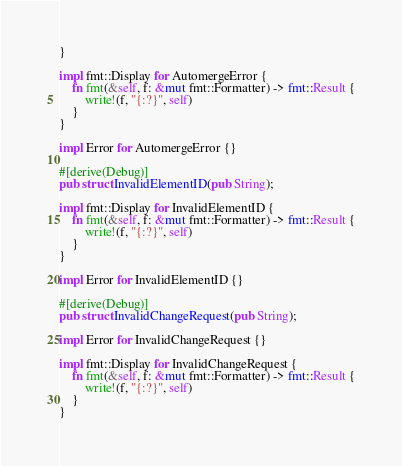<code> <loc_0><loc_0><loc_500><loc_500><_Rust_>}

impl fmt::Display for AutomergeError {
    fn fmt(&self, f: &mut fmt::Formatter) -> fmt::Result {
        write!(f, "{:?}", self)
    }
}

impl Error for AutomergeError {}

#[derive(Debug)]
pub struct InvalidElementID(pub String);

impl fmt::Display for InvalidElementID {
    fn fmt(&self, f: &mut fmt::Formatter) -> fmt::Result {
        write!(f, "{:?}", self)
    }
}

impl Error for InvalidElementID {}

#[derive(Debug)]
pub struct InvalidChangeRequest(pub String);

impl Error for InvalidChangeRequest {}

impl fmt::Display for InvalidChangeRequest {
    fn fmt(&self, f: &mut fmt::Formatter) -> fmt::Result {
        write!(f, "{:?}", self)
    }
}
</code> 